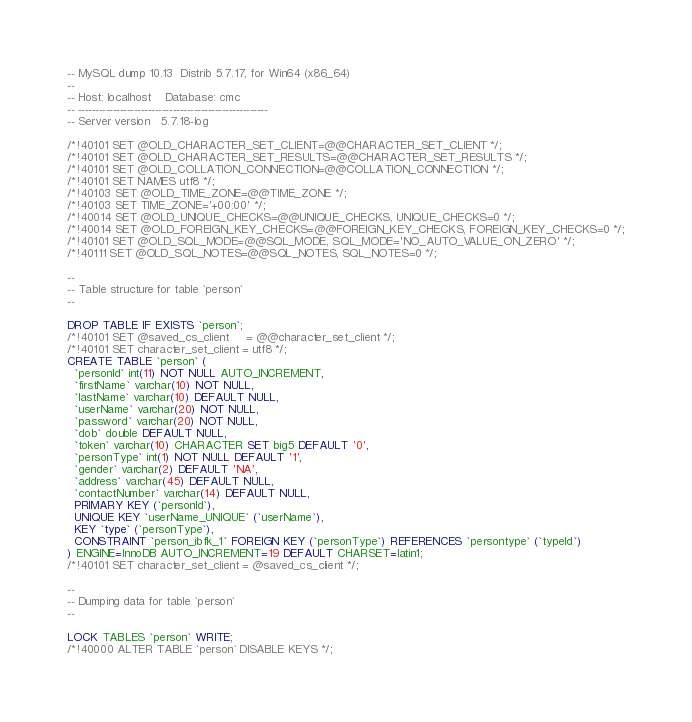<code> <loc_0><loc_0><loc_500><loc_500><_SQL_>-- MySQL dump 10.13  Distrib 5.7.17, for Win64 (x86_64)
--
-- Host: localhost    Database: cmc
-- ------------------------------------------------------
-- Server version	5.7.18-log

/*!40101 SET @OLD_CHARACTER_SET_CLIENT=@@CHARACTER_SET_CLIENT */;
/*!40101 SET @OLD_CHARACTER_SET_RESULTS=@@CHARACTER_SET_RESULTS */;
/*!40101 SET @OLD_COLLATION_CONNECTION=@@COLLATION_CONNECTION */;
/*!40101 SET NAMES utf8 */;
/*!40103 SET @OLD_TIME_ZONE=@@TIME_ZONE */;
/*!40103 SET TIME_ZONE='+00:00' */;
/*!40014 SET @OLD_UNIQUE_CHECKS=@@UNIQUE_CHECKS, UNIQUE_CHECKS=0 */;
/*!40014 SET @OLD_FOREIGN_KEY_CHECKS=@@FOREIGN_KEY_CHECKS, FOREIGN_KEY_CHECKS=0 */;
/*!40101 SET @OLD_SQL_MODE=@@SQL_MODE, SQL_MODE='NO_AUTO_VALUE_ON_ZERO' */;
/*!40111 SET @OLD_SQL_NOTES=@@SQL_NOTES, SQL_NOTES=0 */;

--
-- Table structure for table `person`
--

DROP TABLE IF EXISTS `person`;
/*!40101 SET @saved_cs_client     = @@character_set_client */;
/*!40101 SET character_set_client = utf8 */;
CREATE TABLE `person` (
  `personId` int(11) NOT NULL AUTO_INCREMENT,
  `firstName` varchar(10) NOT NULL,
  `lastName` varchar(10) DEFAULT NULL,
  `userName` varchar(20) NOT NULL,
  `password` varchar(20) NOT NULL,
  `dob` double DEFAULT NULL,
  `token` varchar(10) CHARACTER SET big5 DEFAULT '0',
  `personType` int(1) NOT NULL DEFAULT '1',
  `gender` varchar(2) DEFAULT 'NA',
  `address` varchar(45) DEFAULT NULL,
  `contactNumber` varchar(14) DEFAULT NULL,
  PRIMARY KEY (`personId`),
  UNIQUE KEY `userName_UNIQUE` (`userName`),
  KEY `type` (`personType`),
  CONSTRAINT `person_ibfk_1` FOREIGN KEY (`personType`) REFERENCES `persontype` (`typeId`)
) ENGINE=InnoDB AUTO_INCREMENT=19 DEFAULT CHARSET=latin1;
/*!40101 SET character_set_client = @saved_cs_client */;

--
-- Dumping data for table `person`
--

LOCK TABLES `person` WRITE;
/*!40000 ALTER TABLE `person` DISABLE KEYS */;</code> 